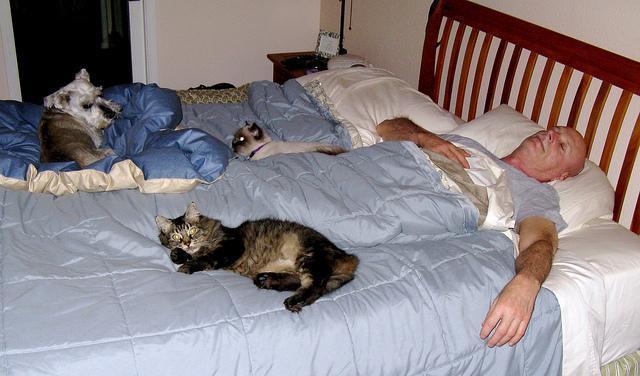How many species rest here?
Choose the correct response and explain in the format: 'Answer: answer
Rationale: rationale.'
Options: Three, none, one, ten. Answer: three.
Rationale: There are cats, a dog, and a person in the bed that add up to 3 species. 